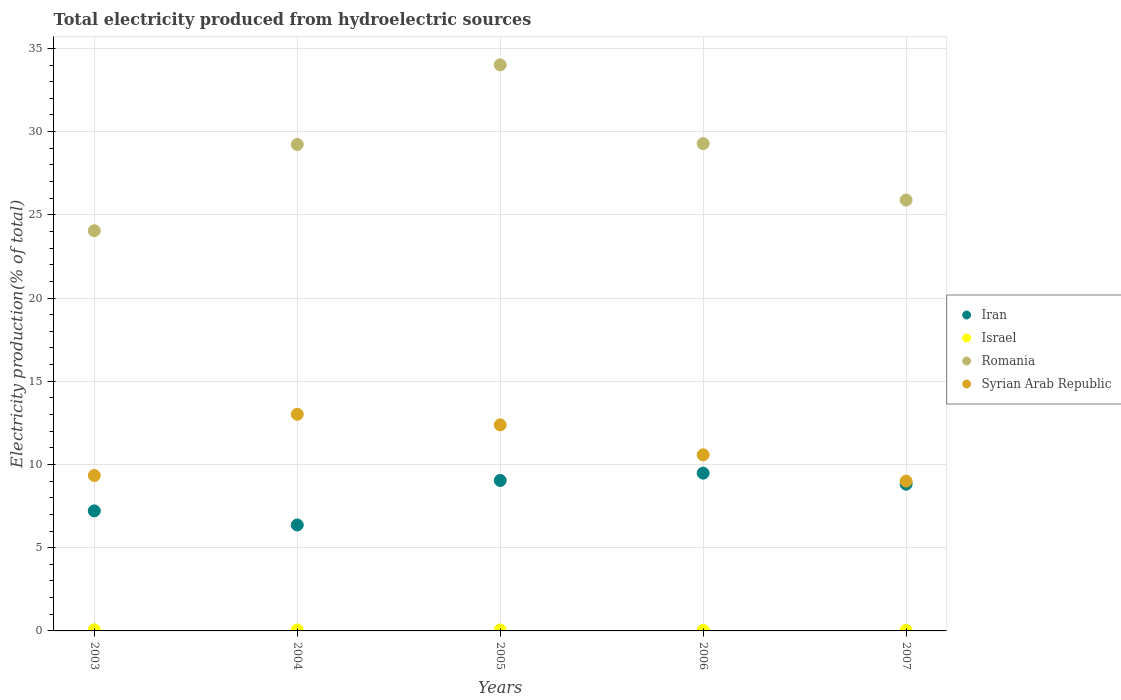How many different coloured dotlines are there?
Your answer should be compact. 4. Is the number of dotlines equal to the number of legend labels?
Your answer should be very brief. Yes. What is the total electricity produced in Romania in 2004?
Offer a terse response. 29.23. Across all years, what is the maximum total electricity produced in Syrian Arab Republic?
Your answer should be compact. 13.02. Across all years, what is the minimum total electricity produced in Syrian Arab Republic?
Provide a succinct answer. 9. In which year was the total electricity produced in Romania maximum?
Keep it short and to the point. 2005. What is the total total electricity produced in Romania in the graph?
Your answer should be compact. 142.45. What is the difference between the total electricity produced in Israel in 2004 and that in 2006?
Your answer should be very brief. 0.03. What is the difference between the total electricity produced in Romania in 2006 and the total electricity produced in Iran in 2007?
Offer a terse response. 20.46. What is the average total electricity produced in Syrian Arab Republic per year?
Offer a very short reply. 10.86. In the year 2006, what is the difference between the total electricity produced in Iran and total electricity produced in Israel?
Your answer should be very brief. 9.45. In how many years, is the total electricity produced in Iran greater than 26 %?
Offer a terse response. 0. What is the ratio of the total electricity produced in Syrian Arab Republic in 2004 to that in 2007?
Your response must be concise. 1.45. What is the difference between the highest and the second highest total electricity produced in Syrian Arab Republic?
Ensure brevity in your answer.  0.64. What is the difference between the highest and the lowest total electricity produced in Romania?
Your response must be concise. 9.97. In how many years, is the total electricity produced in Israel greater than the average total electricity produced in Israel taken over all years?
Ensure brevity in your answer.  3. Is the sum of the total electricity produced in Israel in 2004 and 2005 greater than the maximum total electricity produced in Romania across all years?
Your response must be concise. No. Does the total electricity produced in Romania monotonically increase over the years?
Make the answer very short. No. Is the total electricity produced in Israel strictly greater than the total electricity produced in Iran over the years?
Ensure brevity in your answer.  No. Is the total electricity produced in Iran strictly less than the total electricity produced in Romania over the years?
Your answer should be compact. Yes. How many dotlines are there?
Keep it short and to the point. 4. How many years are there in the graph?
Offer a very short reply. 5. Does the graph contain any zero values?
Offer a very short reply. No. Where does the legend appear in the graph?
Provide a short and direct response. Center right. How are the legend labels stacked?
Make the answer very short. Vertical. What is the title of the graph?
Provide a short and direct response. Total electricity produced from hydroelectric sources. Does "Benin" appear as one of the legend labels in the graph?
Keep it short and to the point. No. What is the label or title of the X-axis?
Your answer should be very brief. Years. What is the label or title of the Y-axis?
Your answer should be very brief. Electricity production(% of total). What is the Electricity production(% of total) of Iran in 2003?
Your answer should be compact. 7.21. What is the Electricity production(% of total) of Israel in 2003?
Your response must be concise. 0.07. What is the Electricity production(% of total) in Romania in 2003?
Ensure brevity in your answer.  24.05. What is the Electricity production(% of total) in Syrian Arab Republic in 2003?
Offer a very short reply. 9.34. What is the Electricity production(% of total) in Iran in 2004?
Your answer should be compact. 6.37. What is the Electricity production(% of total) of Israel in 2004?
Ensure brevity in your answer.  0.06. What is the Electricity production(% of total) in Romania in 2004?
Ensure brevity in your answer.  29.23. What is the Electricity production(% of total) in Syrian Arab Republic in 2004?
Provide a succinct answer. 13.02. What is the Electricity production(% of total) of Iran in 2005?
Your answer should be very brief. 9.04. What is the Electricity production(% of total) of Israel in 2005?
Offer a very short reply. 0.06. What is the Electricity production(% of total) in Romania in 2005?
Keep it short and to the point. 34.01. What is the Electricity production(% of total) of Syrian Arab Republic in 2005?
Your answer should be very brief. 12.38. What is the Electricity production(% of total) of Iran in 2006?
Keep it short and to the point. 9.48. What is the Electricity production(% of total) of Israel in 2006?
Offer a terse response. 0.03. What is the Electricity production(% of total) in Romania in 2006?
Ensure brevity in your answer.  29.28. What is the Electricity production(% of total) of Syrian Arab Republic in 2006?
Give a very brief answer. 10.58. What is the Electricity production(% of total) of Iran in 2007?
Provide a short and direct response. 8.82. What is the Electricity production(% of total) in Israel in 2007?
Keep it short and to the point. 0.03. What is the Electricity production(% of total) of Romania in 2007?
Give a very brief answer. 25.89. What is the Electricity production(% of total) of Syrian Arab Republic in 2007?
Offer a terse response. 9. Across all years, what is the maximum Electricity production(% of total) in Iran?
Your answer should be compact. 9.48. Across all years, what is the maximum Electricity production(% of total) in Israel?
Provide a succinct answer. 0.07. Across all years, what is the maximum Electricity production(% of total) in Romania?
Your answer should be very brief. 34.01. Across all years, what is the maximum Electricity production(% of total) of Syrian Arab Republic?
Offer a very short reply. 13.02. Across all years, what is the minimum Electricity production(% of total) in Iran?
Offer a terse response. 6.37. Across all years, what is the minimum Electricity production(% of total) of Israel?
Offer a very short reply. 0.03. Across all years, what is the minimum Electricity production(% of total) in Romania?
Keep it short and to the point. 24.05. Across all years, what is the minimum Electricity production(% of total) of Syrian Arab Republic?
Ensure brevity in your answer.  9. What is the total Electricity production(% of total) of Iran in the graph?
Provide a short and direct response. 40.92. What is the total Electricity production(% of total) of Israel in the graph?
Keep it short and to the point. 0.24. What is the total Electricity production(% of total) of Romania in the graph?
Ensure brevity in your answer.  142.45. What is the total Electricity production(% of total) of Syrian Arab Republic in the graph?
Your answer should be compact. 54.32. What is the difference between the Electricity production(% of total) of Iran in 2003 and that in 2004?
Provide a succinct answer. 0.85. What is the difference between the Electricity production(% of total) of Israel in 2003 and that in 2004?
Give a very brief answer. 0.01. What is the difference between the Electricity production(% of total) of Romania in 2003 and that in 2004?
Your response must be concise. -5.18. What is the difference between the Electricity production(% of total) of Syrian Arab Republic in 2003 and that in 2004?
Your answer should be very brief. -3.68. What is the difference between the Electricity production(% of total) of Iran in 2003 and that in 2005?
Keep it short and to the point. -1.83. What is the difference between the Electricity production(% of total) of Israel in 2003 and that in 2005?
Make the answer very short. 0.01. What is the difference between the Electricity production(% of total) in Romania in 2003 and that in 2005?
Offer a very short reply. -9.96. What is the difference between the Electricity production(% of total) in Syrian Arab Republic in 2003 and that in 2005?
Offer a very short reply. -3.04. What is the difference between the Electricity production(% of total) of Iran in 2003 and that in 2006?
Provide a succinct answer. -2.27. What is the difference between the Electricity production(% of total) of Israel in 2003 and that in 2006?
Ensure brevity in your answer.  0.04. What is the difference between the Electricity production(% of total) of Romania in 2003 and that in 2006?
Offer a terse response. -5.23. What is the difference between the Electricity production(% of total) of Syrian Arab Republic in 2003 and that in 2006?
Your answer should be compact. -1.24. What is the difference between the Electricity production(% of total) of Iran in 2003 and that in 2007?
Keep it short and to the point. -1.61. What is the difference between the Electricity production(% of total) of Israel in 2003 and that in 2007?
Provide a short and direct response. 0.04. What is the difference between the Electricity production(% of total) of Romania in 2003 and that in 2007?
Your response must be concise. -1.84. What is the difference between the Electricity production(% of total) in Syrian Arab Republic in 2003 and that in 2007?
Your answer should be compact. 0.34. What is the difference between the Electricity production(% of total) of Iran in 2004 and that in 2005?
Give a very brief answer. -2.67. What is the difference between the Electricity production(% of total) in Israel in 2004 and that in 2005?
Your answer should be compact. 0. What is the difference between the Electricity production(% of total) in Romania in 2004 and that in 2005?
Offer a terse response. -4.78. What is the difference between the Electricity production(% of total) in Syrian Arab Republic in 2004 and that in 2005?
Give a very brief answer. 0.64. What is the difference between the Electricity production(% of total) of Iran in 2004 and that in 2006?
Your response must be concise. -3.11. What is the difference between the Electricity production(% of total) of Israel in 2004 and that in 2006?
Your response must be concise. 0.03. What is the difference between the Electricity production(% of total) of Romania in 2004 and that in 2006?
Provide a short and direct response. -0.05. What is the difference between the Electricity production(% of total) of Syrian Arab Republic in 2004 and that in 2006?
Give a very brief answer. 2.43. What is the difference between the Electricity production(% of total) of Iran in 2004 and that in 2007?
Your answer should be very brief. -2.45. What is the difference between the Electricity production(% of total) of Israel in 2004 and that in 2007?
Your response must be concise. 0.03. What is the difference between the Electricity production(% of total) of Romania in 2004 and that in 2007?
Offer a very short reply. 3.34. What is the difference between the Electricity production(% of total) in Syrian Arab Republic in 2004 and that in 2007?
Your response must be concise. 4.01. What is the difference between the Electricity production(% of total) of Iran in 2005 and that in 2006?
Offer a very short reply. -0.44. What is the difference between the Electricity production(% of total) in Israel in 2005 and that in 2006?
Keep it short and to the point. 0.03. What is the difference between the Electricity production(% of total) in Romania in 2005 and that in 2006?
Your response must be concise. 4.73. What is the difference between the Electricity production(% of total) in Syrian Arab Republic in 2005 and that in 2006?
Provide a short and direct response. 1.8. What is the difference between the Electricity production(% of total) of Iran in 2005 and that in 2007?
Offer a very short reply. 0.22. What is the difference between the Electricity production(% of total) of Israel in 2005 and that in 2007?
Offer a terse response. 0.03. What is the difference between the Electricity production(% of total) of Romania in 2005 and that in 2007?
Give a very brief answer. 8.12. What is the difference between the Electricity production(% of total) in Syrian Arab Republic in 2005 and that in 2007?
Offer a very short reply. 3.38. What is the difference between the Electricity production(% of total) in Iran in 2006 and that in 2007?
Offer a very short reply. 0.66. What is the difference between the Electricity production(% of total) of Israel in 2006 and that in 2007?
Give a very brief answer. 0. What is the difference between the Electricity production(% of total) in Romania in 2006 and that in 2007?
Your response must be concise. 3.39. What is the difference between the Electricity production(% of total) in Syrian Arab Republic in 2006 and that in 2007?
Your response must be concise. 1.58. What is the difference between the Electricity production(% of total) in Iran in 2003 and the Electricity production(% of total) in Israel in 2004?
Ensure brevity in your answer.  7.15. What is the difference between the Electricity production(% of total) in Iran in 2003 and the Electricity production(% of total) in Romania in 2004?
Your response must be concise. -22.01. What is the difference between the Electricity production(% of total) of Iran in 2003 and the Electricity production(% of total) of Syrian Arab Republic in 2004?
Give a very brief answer. -5.8. What is the difference between the Electricity production(% of total) of Israel in 2003 and the Electricity production(% of total) of Romania in 2004?
Make the answer very short. -29.16. What is the difference between the Electricity production(% of total) in Israel in 2003 and the Electricity production(% of total) in Syrian Arab Republic in 2004?
Provide a succinct answer. -12.95. What is the difference between the Electricity production(% of total) in Romania in 2003 and the Electricity production(% of total) in Syrian Arab Republic in 2004?
Provide a succinct answer. 11.03. What is the difference between the Electricity production(% of total) of Iran in 2003 and the Electricity production(% of total) of Israel in 2005?
Your answer should be very brief. 7.15. What is the difference between the Electricity production(% of total) in Iran in 2003 and the Electricity production(% of total) in Romania in 2005?
Your response must be concise. -26.8. What is the difference between the Electricity production(% of total) of Iran in 2003 and the Electricity production(% of total) of Syrian Arab Republic in 2005?
Offer a very short reply. -5.17. What is the difference between the Electricity production(% of total) of Israel in 2003 and the Electricity production(% of total) of Romania in 2005?
Offer a terse response. -33.95. What is the difference between the Electricity production(% of total) in Israel in 2003 and the Electricity production(% of total) in Syrian Arab Republic in 2005?
Provide a short and direct response. -12.31. What is the difference between the Electricity production(% of total) of Romania in 2003 and the Electricity production(% of total) of Syrian Arab Republic in 2005?
Your answer should be compact. 11.67. What is the difference between the Electricity production(% of total) in Iran in 2003 and the Electricity production(% of total) in Israel in 2006?
Offer a very short reply. 7.18. What is the difference between the Electricity production(% of total) in Iran in 2003 and the Electricity production(% of total) in Romania in 2006?
Offer a very short reply. -22.07. What is the difference between the Electricity production(% of total) of Iran in 2003 and the Electricity production(% of total) of Syrian Arab Republic in 2006?
Offer a very short reply. -3.37. What is the difference between the Electricity production(% of total) in Israel in 2003 and the Electricity production(% of total) in Romania in 2006?
Ensure brevity in your answer.  -29.21. What is the difference between the Electricity production(% of total) in Israel in 2003 and the Electricity production(% of total) in Syrian Arab Republic in 2006?
Give a very brief answer. -10.52. What is the difference between the Electricity production(% of total) of Romania in 2003 and the Electricity production(% of total) of Syrian Arab Republic in 2006?
Make the answer very short. 13.46. What is the difference between the Electricity production(% of total) of Iran in 2003 and the Electricity production(% of total) of Israel in 2007?
Make the answer very short. 7.19. What is the difference between the Electricity production(% of total) of Iran in 2003 and the Electricity production(% of total) of Romania in 2007?
Provide a short and direct response. -18.68. What is the difference between the Electricity production(% of total) in Iran in 2003 and the Electricity production(% of total) in Syrian Arab Republic in 2007?
Keep it short and to the point. -1.79. What is the difference between the Electricity production(% of total) in Israel in 2003 and the Electricity production(% of total) in Romania in 2007?
Offer a very short reply. -25.82. What is the difference between the Electricity production(% of total) of Israel in 2003 and the Electricity production(% of total) of Syrian Arab Republic in 2007?
Give a very brief answer. -8.93. What is the difference between the Electricity production(% of total) of Romania in 2003 and the Electricity production(% of total) of Syrian Arab Republic in 2007?
Keep it short and to the point. 15.05. What is the difference between the Electricity production(% of total) in Iran in 2004 and the Electricity production(% of total) in Israel in 2005?
Ensure brevity in your answer.  6.31. What is the difference between the Electricity production(% of total) in Iran in 2004 and the Electricity production(% of total) in Romania in 2005?
Provide a succinct answer. -27.64. What is the difference between the Electricity production(% of total) of Iran in 2004 and the Electricity production(% of total) of Syrian Arab Republic in 2005?
Your answer should be very brief. -6.01. What is the difference between the Electricity production(% of total) of Israel in 2004 and the Electricity production(% of total) of Romania in 2005?
Make the answer very short. -33.95. What is the difference between the Electricity production(% of total) in Israel in 2004 and the Electricity production(% of total) in Syrian Arab Republic in 2005?
Offer a very short reply. -12.32. What is the difference between the Electricity production(% of total) in Romania in 2004 and the Electricity production(% of total) in Syrian Arab Republic in 2005?
Your response must be concise. 16.85. What is the difference between the Electricity production(% of total) in Iran in 2004 and the Electricity production(% of total) in Israel in 2006?
Provide a succinct answer. 6.34. What is the difference between the Electricity production(% of total) in Iran in 2004 and the Electricity production(% of total) in Romania in 2006?
Offer a very short reply. -22.91. What is the difference between the Electricity production(% of total) in Iran in 2004 and the Electricity production(% of total) in Syrian Arab Republic in 2006?
Provide a succinct answer. -4.21. What is the difference between the Electricity production(% of total) of Israel in 2004 and the Electricity production(% of total) of Romania in 2006?
Give a very brief answer. -29.22. What is the difference between the Electricity production(% of total) of Israel in 2004 and the Electricity production(% of total) of Syrian Arab Republic in 2006?
Ensure brevity in your answer.  -10.52. What is the difference between the Electricity production(% of total) in Romania in 2004 and the Electricity production(% of total) in Syrian Arab Republic in 2006?
Your answer should be compact. 18.65. What is the difference between the Electricity production(% of total) in Iran in 2004 and the Electricity production(% of total) in Israel in 2007?
Ensure brevity in your answer.  6.34. What is the difference between the Electricity production(% of total) of Iran in 2004 and the Electricity production(% of total) of Romania in 2007?
Your response must be concise. -19.52. What is the difference between the Electricity production(% of total) of Iran in 2004 and the Electricity production(% of total) of Syrian Arab Republic in 2007?
Make the answer very short. -2.63. What is the difference between the Electricity production(% of total) in Israel in 2004 and the Electricity production(% of total) in Romania in 2007?
Give a very brief answer. -25.83. What is the difference between the Electricity production(% of total) in Israel in 2004 and the Electricity production(% of total) in Syrian Arab Republic in 2007?
Offer a terse response. -8.94. What is the difference between the Electricity production(% of total) of Romania in 2004 and the Electricity production(% of total) of Syrian Arab Republic in 2007?
Make the answer very short. 20.23. What is the difference between the Electricity production(% of total) of Iran in 2005 and the Electricity production(% of total) of Israel in 2006?
Your response must be concise. 9.01. What is the difference between the Electricity production(% of total) in Iran in 2005 and the Electricity production(% of total) in Romania in 2006?
Give a very brief answer. -20.24. What is the difference between the Electricity production(% of total) of Iran in 2005 and the Electricity production(% of total) of Syrian Arab Republic in 2006?
Offer a very short reply. -1.54. What is the difference between the Electricity production(% of total) of Israel in 2005 and the Electricity production(% of total) of Romania in 2006?
Provide a succinct answer. -29.22. What is the difference between the Electricity production(% of total) of Israel in 2005 and the Electricity production(% of total) of Syrian Arab Republic in 2006?
Ensure brevity in your answer.  -10.52. What is the difference between the Electricity production(% of total) in Romania in 2005 and the Electricity production(% of total) in Syrian Arab Republic in 2006?
Your response must be concise. 23.43. What is the difference between the Electricity production(% of total) of Iran in 2005 and the Electricity production(% of total) of Israel in 2007?
Make the answer very short. 9.01. What is the difference between the Electricity production(% of total) of Iran in 2005 and the Electricity production(% of total) of Romania in 2007?
Keep it short and to the point. -16.85. What is the difference between the Electricity production(% of total) in Iran in 2005 and the Electricity production(% of total) in Syrian Arab Republic in 2007?
Provide a short and direct response. 0.04. What is the difference between the Electricity production(% of total) of Israel in 2005 and the Electricity production(% of total) of Romania in 2007?
Keep it short and to the point. -25.83. What is the difference between the Electricity production(% of total) of Israel in 2005 and the Electricity production(% of total) of Syrian Arab Republic in 2007?
Offer a terse response. -8.94. What is the difference between the Electricity production(% of total) of Romania in 2005 and the Electricity production(% of total) of Syrian Arab Republic in 2007?
Offer a terse response. 25.01. What is the difference between the Electricity production(% of total) of Iran in 2006 and the Electricity production(% of total) of Israel in 2007?
Give a very brief answer. 9.45. What is the difference between the Electricity production(% of total) of Iran in 2006 and the Electricity production(% of total) of Romania in 2007?
Give a very brief answer. -16.41. What is the difference between the Electricity production(% of total) of Iran in 2006 and the Electricity production(% of total) of Syrian Arab Republic in 2007?
Your response must be concise. 0.48. What is the difference between the Electricity production(% of total) in Israel in 2006 and the Electricity production(% of total) in Romania in 2007?
Offer a very short reply. -25.86. What is the difference between the Electricity production(% of total) of Israel in 2006 and the Electricity production(% of total) of Syrian Arab Republic in 2007?
Provide a short and direct response. -8.97. What is the difference between the Electricity production(% of total) in Romania in 2006 and the Electricity production(% of total) in Syrian Arab Republic in 2007?
Provide a short and direct response. 20.28. What is the average Electricity production(% of total) in Iran per year?
Offer a very short reply. 8.18. What is the average Electricity production(% of total) of Israel per year?
Offer a very short reply. 0.05. What is the average Electricity production(% of total) of Romania per year?
Keep it short and to the point. 28.49. What is the average Electricity production(% of total) in Syrian Arab Republic per year?
Your response must be concise. 10.86. In the year 2003, what is the difference between the Electricity production(% of total) in Iran and Electricity production(% of total) in Israel?
Offer a terse response. 7.15. In the year 2003, what is the difference between the Electricity production(% of total) in Iran and Electricity production(% of total) in Romania?
Give a very brief answer. -16.83. In the year 2003, what is the difference between the Electricity production(% of total) of Iran and Electricity production(% of total) of Syrian Arab Republic?
Provide a succinct answer. -2.13. In the year 2003, what is the difference between the Electricity production(% of total) of Israel and Electricity production(% of total) of Romania?
Ensure brevity in your answer.  -23.98. In the year 2003, what is the difference between the Electricity production(% of total) of Israel and Electricity production(% of total) of Syrian Arab Republic?
Keep it short and to the point. -9.27. In the year 2003, what is the difference between the Electricity production(% of total) of Romania and Electricity production(% of total) of Syrian Arab Republic?
Offer a very short reply. 14.71. In the year 2004, what is the difference between the Electricity production(% of total) in Iran and Electricity production(% of total) in Israel?
Offer a very short reply. 6.31. In the year 2004, what is the difference between the Electricity production(% of total) in Iran and Electricity production(% of total) in Romania?
Offer a terse response. -22.86. In the year 2004, what is the difference between the Electricity production(% of total) of Iran and Electricity production(% of total) of Syrian Arab Republic?
Your response must be concise. -6.65. In the year 2004, what is the difference between the Electricity production(% of total) in Israel and Electricity production(% of total) in Romania?
Offer a very short reply. -29.17. In the year 2004, what is the difference between the Electricity production(% of total) in Israel and Electricity production(% of total) in Syrian Arab Republic?
Offer a terse response. -12.96. In the year 2004, what is the difference between the Electricity production(% of total) in Romania and Electricity production(% of total) in Syrian Arab Republic?
Offer a very short reply. 16.21. In the year 2005, what is the difference between the Electricity production(% of total) in Iran and Electricity production(% of total) in Israel?
Your answer should be compact. 8.98. In the year 2005, what is the difference between the Electricity production(% of total) of Iran and Electricity production(% of total) of Romania?
Your response must be concise. -24.97. In the year 2005, what is the difference between the Electricity production(% of total) in Iran and Electricity production(% of total) in Syrian Arab Republic?
Offer a terse response. -3.34. In the year 2005, what is the difference between the Electricity production(% of total) in Israel and Electricity production(% of total) in Romania?
Ensure brevity in your answer.  -33.95. In the year 2005, what is the difference between the Electricity production(% of total) of Israel and Electricity production(% of total) of Syrian Arab Republic?
Ensure brevity in your answer.  -12.32. In the year 2005, what is the difference between the Electricity production(% of total) in Romania and Electricity production(% of total) in Syrian Arab Republic?
Provide a succinct answer. 21.63. In the year 2006, what is the difference between the Electricity production(% of total) of Iran and Electricity production(% of total) of Israel?
Give a very brief answer. 9.45. In the year 2006, what is the difference between the Electricity production(% of total) in Iran and Electricity production(% of total) in Romania?
Your response must be concise. -19.8. In the year 2006, what is the difference between the Electricity production(% of total) in Iran and Electricity production(% of total) in Syrian Arab Republic?
Give a very brief answer. -1.1. In the year 2006, what is the difference between the Electricity production(% of total) of Israel and Electricity production(% of total) of Romania?
Provide a short and direct response. -29.25. In the year 2006, what is the difference between the Electricity production(% of total) in Israel and Electricity production(% of total) in Syrian Arab Republic?
Keep it short and to the point. -10.55. In the year 2006, what is the difference between the Electricity production(% of total) in Romania and Electricity production(% of total) in Syrian Arab Republic?
Offer a terse response. 18.7. In the year 2007, what is the difference between the Electricity production(% of total) in Iran and Electricity production(% of total) in Israel?
Keep it short and to the point. 8.79. In the year 2007, what is the difference between the Electricity production(% of total) in Iran and Electricity production(% of total) in Romania?
Your response must be concise. -17.07. In the year 2007, what is the difference between the Electricity production(% of total) in Iran and Electricity production(% of total) in Syrian Arab Republic?
Provide a succinct answer. -0.18. In the year 2007, what is the difference between the Electricity production(% of total) of Israel and Electricity production(% of total) of Romania?
Offer a terse response. -25.86. In the year 2007, what is the difference between the Electricity production(% of total) of Israel and Electricity production(% of total) of Syrian Arab Republic?
Provide a short and direct response. -8.97. In the year 2007, what is the difference between the Electricity production(% of total) of Romania and Electricity production(% of total) of Syrian Arab Republic?
Your answer should be compact. 16.89. What is the ratio of the Electricity production(% of total) of Iran in 2003 to that in 2004?
Keep it short and to the point. 1.13. What is the ratio of the Electricity production(% of total) in Israel in 2003 to that in 2004?
Provide a succinct answer. 1.11. What is the ratio of the Electricity production(% of total) in Romania in 2003 to that in 2004?
Your answer should be compact. 0.82. What is the ratio of the Electricity production(% of total) in Syrian Arab Republic in 2003 to that in 2004?
Your response must be concise. 0.72. What is the ratio of the Electricity production(% of total) in Iran in 2003 to that in 2005?
Offer a terse response. 0.8. What is the ratio of the Electricity production(% of total) in Israel in 2003 to that in 2005?
Offer a very short reply. 1.14. What is the ratio of the Electricity production(% of total) of Romania in 2003 to that in 2005?
Keep it short and to the point. 0.71. What is the ratio of the Electricity production(% of total) of Syrian Arab Republic in 2003 to that in 2005?
Give a very brief answer. 0.75. What is the ratio of the Electricity production(% of total) in Iran in 2003 to that in 2006?
Offer a very short reply. 0.76. What is the ratio of the Electricity production(% of total) of Israel in 2003 to that in 2006?
Your answer should be compact. 2.22. What is the ratio of the Electricity production(% of total) in Romania in 2003 to that in 2006?
Provide a short and direct response. 0.82. What is the ratio of the Electricity production(% of total) in Syrian Arab Republic in 2003 to that in 2006?
Offer a very short reply. 0.88. What is the ratio of the Electricity production(% of total) of Iran in 2003 to that in 2007?
Provide a succinct answer. 0.82. What is the ratio of the Electricity production(% of total) of Israel in 2003 to that in 2007?
Ensure brevity in your answer.  2.53. What is the ratio of the Electricity production(% of total) in Romania in 2003 to that in 2007?
Provide a succinct answer. 0.93. What is the ratio of the Electricity production(% of total) in Syrian Arab Republic in 2003 to that in 2007?
Your answer should be very brief. 1.04. What is the ratio of the Electricity production(% of total) in Iran in 2004 to that in 2005?
Offer a terse response. 0.7. What is the ratio of the Electricity production(% of total) in Israel in 2004 to that in 2005?
Offer a very short reply. 1.03. What is the ratio of the Electricity production(% of total) of Romania in 2004 to that in 2005?
Make the answer very short. 0.86. What is the ratio of the Electricity production(% of total) of Syrian Arab Republic in 2004 to that in 2005?
Make the answer very short. 1.05. What is the ratio of the Electricity production(% of total) in Iran in 2004 to that in 2006?
Make the answer very short. 0.67. What is the ratio of the Electricity production(% of total) in Israel in 2004 to that in 2006?
Make the answer very short. 2. What is the ratio of the Electricity production(% of total) in Romania in 2004 to that in 2006?
Ensure brevity in your answer.  1. What is the ratio of the Electricity production(% of total) of Syrian Arab Republic in 2004 to that in 2006?
Your response must be concise. 1.23. What is the ratio of the Electricity production(% of total) in Iran in 2004 to that in 2007?
Offer a terse response. 0.72. What is the ratio of the Electricity production(% of total) in Israel in 2004 to that in 2007?
Provide a succinct answer. 2.28. What is the ratio of the Electricity production(% of total) of Romania in 2004 to that in 2007?
Offer a terse response. 1.13. What is the ratio of the Electricity production(% of total) of Syrian Arab Republic in 2004 to that in 2007?
Your answer should be compact. 1.45. What is the ratio of the Electricity production(% of total) in Iran in 2005 to that in 2006?
Your response must be concise. 0.95. What is the ratio of the Electricity production(% of total) of Israel in 2005 to that in 2006?
Your answer should be compact. 1.94. What is the ratio of the Electricity production(% of total) in Romania in 2005 to that in 2006?
Your answer should be very brief. 1.16. What is the ratio of the Electricity production(% of total) in Syrian Arab Republic in 2005 to that in 2006?
Your answer should be very brief. 1.17. What is the ratio of the Electricity production(% of total) of Iran in 2005 to that in 2007?
Provide a succinct answer. 1.03. What is the ratio of the Electricity production(% of total) in Israel in 2005 to that in 2007?
Ensure brevity in your answer.  2.21. What is the ratio of the Electricity production(% of total) of Romania in 2005 to that in 2007?
Your response must be concise. 1.31. What is the ratio of the Electricity production(% of total) in Syrian Arab Republic in 2005 to that in 2007?
Ensure brevity in your answer.  1.38. What is the ratio of the Electricity production(% of total) of Iran in 2006 to that in 2007?
Provide a succinct answer. 1.08. What is the ratio of the Electricity production(% of total) of Israel in 2006 to that in 2007?
Provide a succinct answer. 1.14. What is the ratio of the Electricity production(% of total) in Romania in 2006 to that in 2007?
Provide a short and direct response. 1.13. What is the ratio of the Electricity production(% of total) of Syrian Arab Republic in 2006 to that in 2007?
Offer a very short reply. 1.18. What is the difference between the highest and the second highest Electricity production(% of total) of Iran?
Offer a terse response. 0.44. What is the difference between the highest and the second highest Electricity production(% of total) in Israel?
Provide a short and direct response. 0.01. What is the difference between the highest and the second highest Electricity production(% of total) in Romania?
Your answer should be very brief. 4.73. What is the difference between the highest and the second highest Electricity production(% of total) in Syrian Arab Republic?
Give a very brief answer. 0.64. What is the difference between the highest and the lowest Electricity production(% of total) in Iran?
Make the answer very short. 3.11. What is the difference between the highest and the lowest Electricity production(% of total) of Israel?
Provide a short and direct response. 0.04. What is the difference between the highest and the lowest Electricity production(% of total) in Romania?
Offer a very short reply. 9.96. What is the difference between the highest and the lowest Electricity production(% of total) in Syrian Arab Republic?
Ensure brevity in your answer.  4.01. 